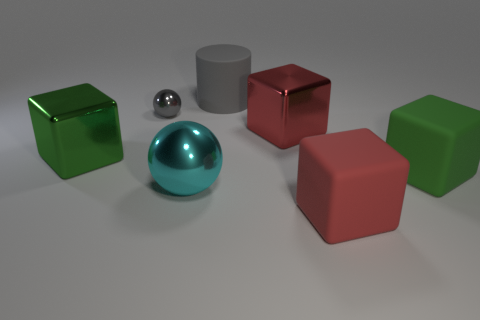What is the shape of the red metal thing that is the same size as the gray matte thing?
Offer a terse response. Cube. There is a green block on the left side of the big object behind the gray metal thing; are there any red metallic blocks in front of it?
Provide a short and direct response. No. Are there any red shiny blocks of the same size as the red matte cube?
Your answer should be compact. Yes. There is a shiny thing that is in front of the green metal block; what size is it?
Provide a short and direct response. Large. What color is the object that is on the left side of the gray metal object behind the red rubber block in front of the cyan metallic object?
Your answer should be compact. Green. The cube that is in front of the metallic ball that is in front of the tiny gray thing is what color?
Ensure brevity in your answer.  Red. Are there more large green shiny blocks that are to the right of the big red matte cube than large green rubber blocks behind the big gray object?
Your answer should be compact. No. Is the material of the green object to the right of the gray metallic sphere the same as the green thing that is on the left side of the small thing?
Ensure brevity in your answer.  No. Are there any tiny gray metal balls behind the big gray object?
Provide a succinct answer. No. How many green objects are shiny cubes or big rubber cubes?
Ensure brevity in your answer.  2. 